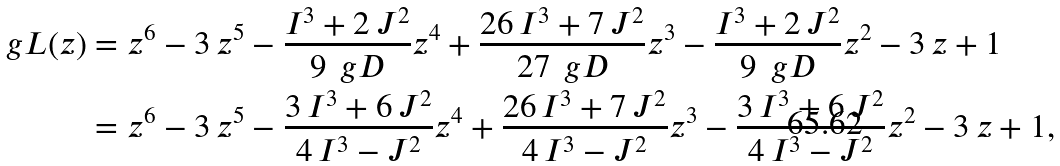Convert formula to latex. <formula><loc_0><loc_0><loc_500><loc_500>\ g L ( z ) & = z ^ { 6 } - 3 \, z ^ { 5 } - \frac { I ^ { 3 } + 2 \, J ^ { 2 } } { 9 \, \ g D } z ^ { 4 } + \frac { 2 6 \, I ^ { 3 } + 7 \, J ^ { 2 } } { 2 7 \, \ g D } z ^ { 3 } - \frac { I ^ { 3 } + 2 \, J ^ { 2 } } { 9 \, \ g D } z ^ { 2 } - 3 \, z + 1 \\ & = z ^ { 6 } - 3 \, z ^ { 5 } - \frac { 3 \, I ^ { 3 } + 6 \, J ^ { 2 } } { 4 \, I ^ { 3 } - J ^ { 2 } } z ^ { 4 } + \frac { 2 6 \, I ^ { 3 } + 7 \, J ^ { 2 } } { 4 \, I ^ { 3 } - J ^ { 2 } } z ^ { 3 } - \frac { 3 \, I ^ { 3 } + 6 \, J ^ { 2 } } { 4 \, I ^ { 3 } - J ^ { 2 } } z ^ { 2 } - 3 \, z + 1 ,</formula> 